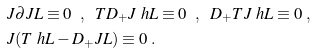Convert formula to latex. <formula><loc_0><loc_0><loc_500><loc_500>& J \partial J L \equiv 0 \ \ , \ \ T D _ { + } J \ h L \equiv 0 \ \ , \ \ D _ { + } T J \ h L \equiv 0 \ , \\ & J ( T \ h L - D _ { + } J L ) \equiv 0 \ .</formula> 